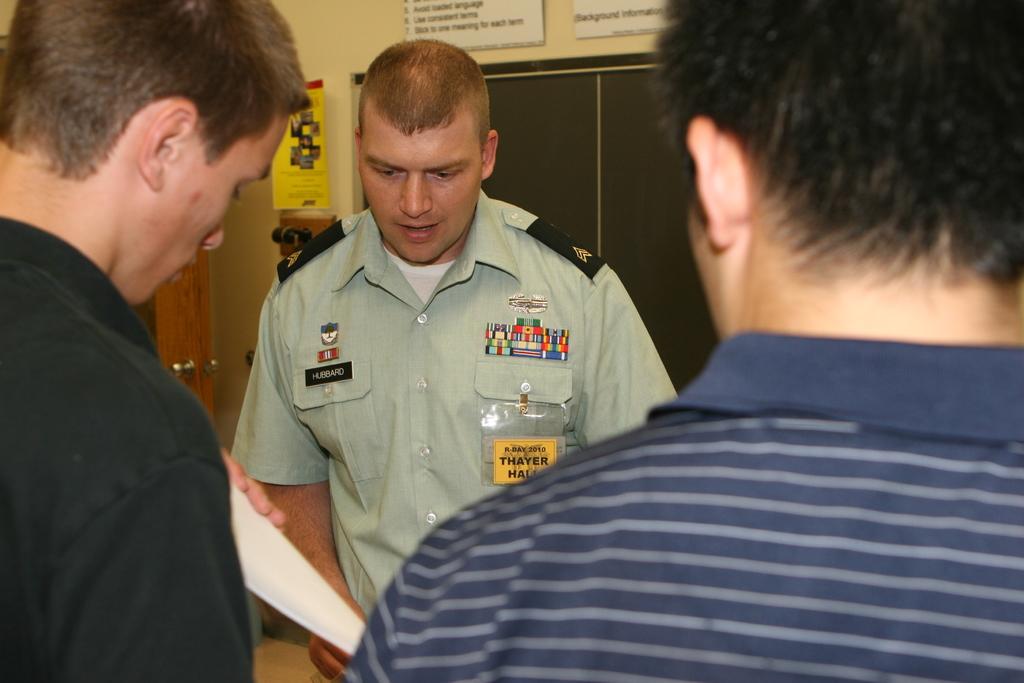What year is on his badge?
Offer a very short reply. 2010. 